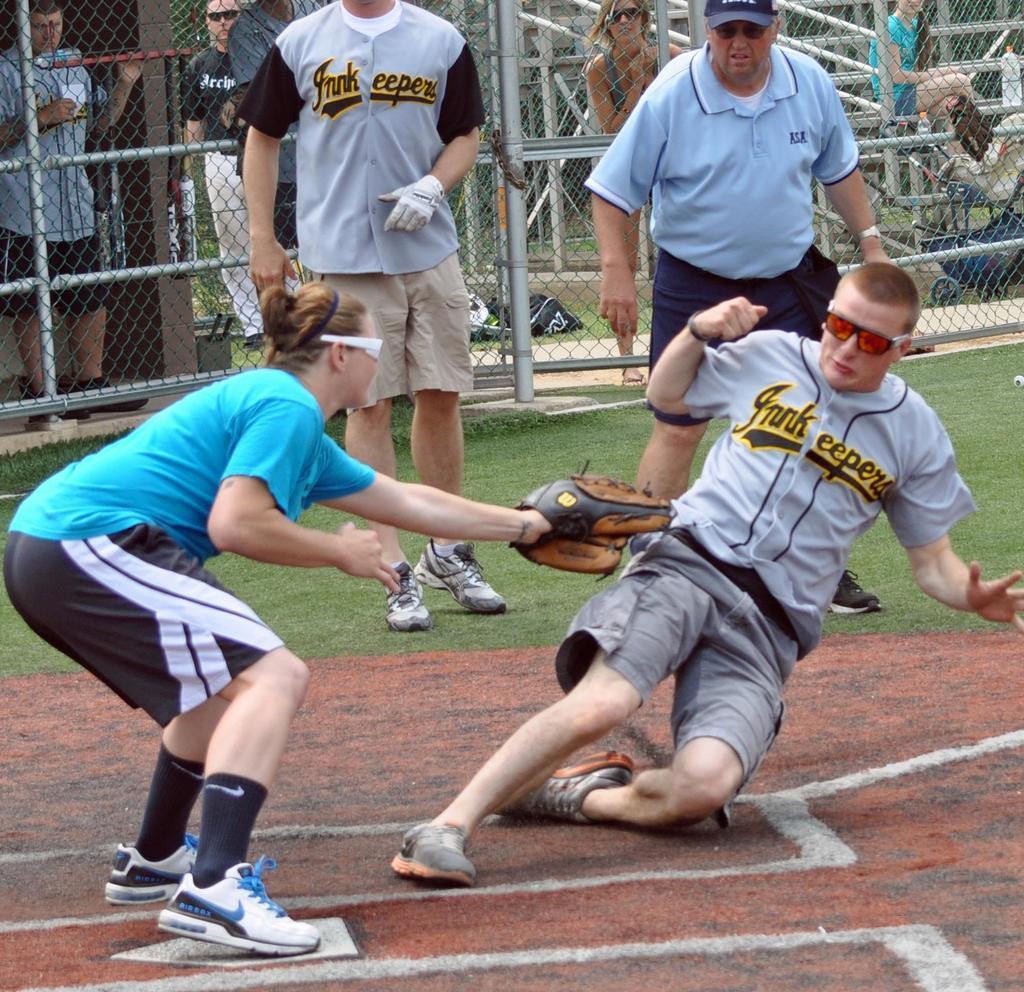Can you describe this image briefly? In this image four people were playing. At the background people were standing. At the backside of the image fencing was done. 